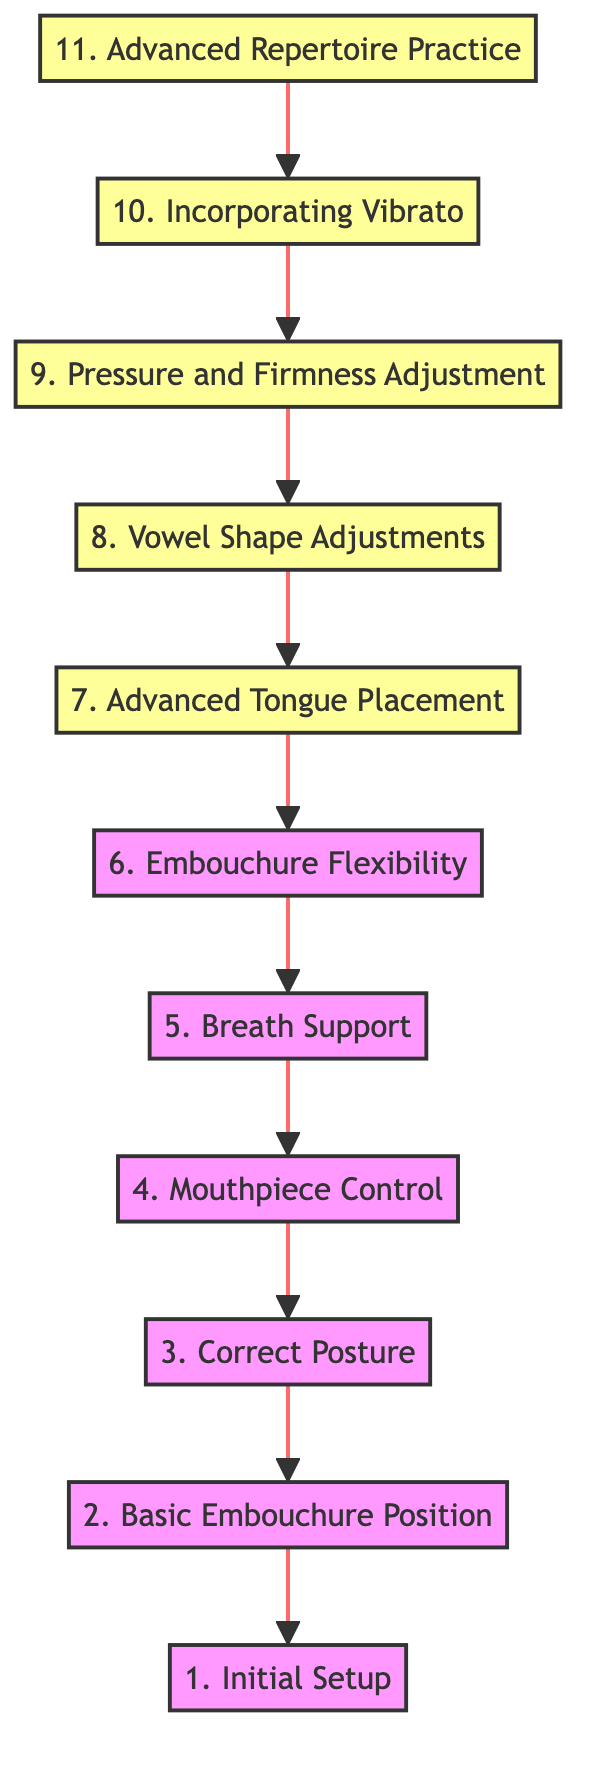What is the first step in improving clarinet embouchure? The diagram indicates that the first step is “1. Initial Setup.” This is the bottom node in the flowchart and signifies the starting point of the process.
Answer: Initial Setup How many nodes are present in the diagram? By counting the number of distinct steps listed from “1. Initial Setup” to “11. Advanced Repertoire Practice,” there are a total of 11 nodes in the flowchart.
Answer: 11 What follows after "Mouthpiece Control" in the diagram? Looking at the flow from the bottom to the top, “Breath Support” follows immediately after “Mouthpiece Control.” This can be identified as the direct upward connection from mouthpiece control.
Answer: Breath Support Which step involves "experimenting with different vowel shapes"? The diagram specifies “8. Vowel Shape Adjustments” as the step that involves experimenting with different vowel shapes. This node is positioned after “Pressure and Firmness Adjustment.”
Answer: Vowel Shape Adjustments What is the final step before "Advanced Repertoire Practice"? Examining the diagram, the step immediately preceding “11. Advanced Repertoire Practice” is “10. Incorporating Vibrato.” This indicates that vibrato is integrated just before approaching advanced pieces.
Answer: Incorporating Vibrato Which two steps are directly connected to "Embracing Flexibility"? The step “6. Embouchure Flexibility” directly connects to both “5. Breath Support” and “7. Advanced Tongue Placement.” This illustrates the relationship between these important techniques in embouchure improvement.
Answer: Breath Support, Advanced Tongue Placement Which step is focused on diaphragm usage? The flowchart specifies “5. Breath Support” as the step that emphasizes the use of diaphragmatic breathing, indicating its crucial role in sound projection.
Answer: Breath Support What is the primary focus of "Pressure and Firmness Adjustment"? The step “9. Pressure and Firmness Adjustment” primarily focuses on fine-tuning the pressure of the lips and the firmness of the embouchure around the mouthpiece to control intonation. This specific detail is mentioned in its description.
Answer: Pressure of lips, firmness of embouchure 